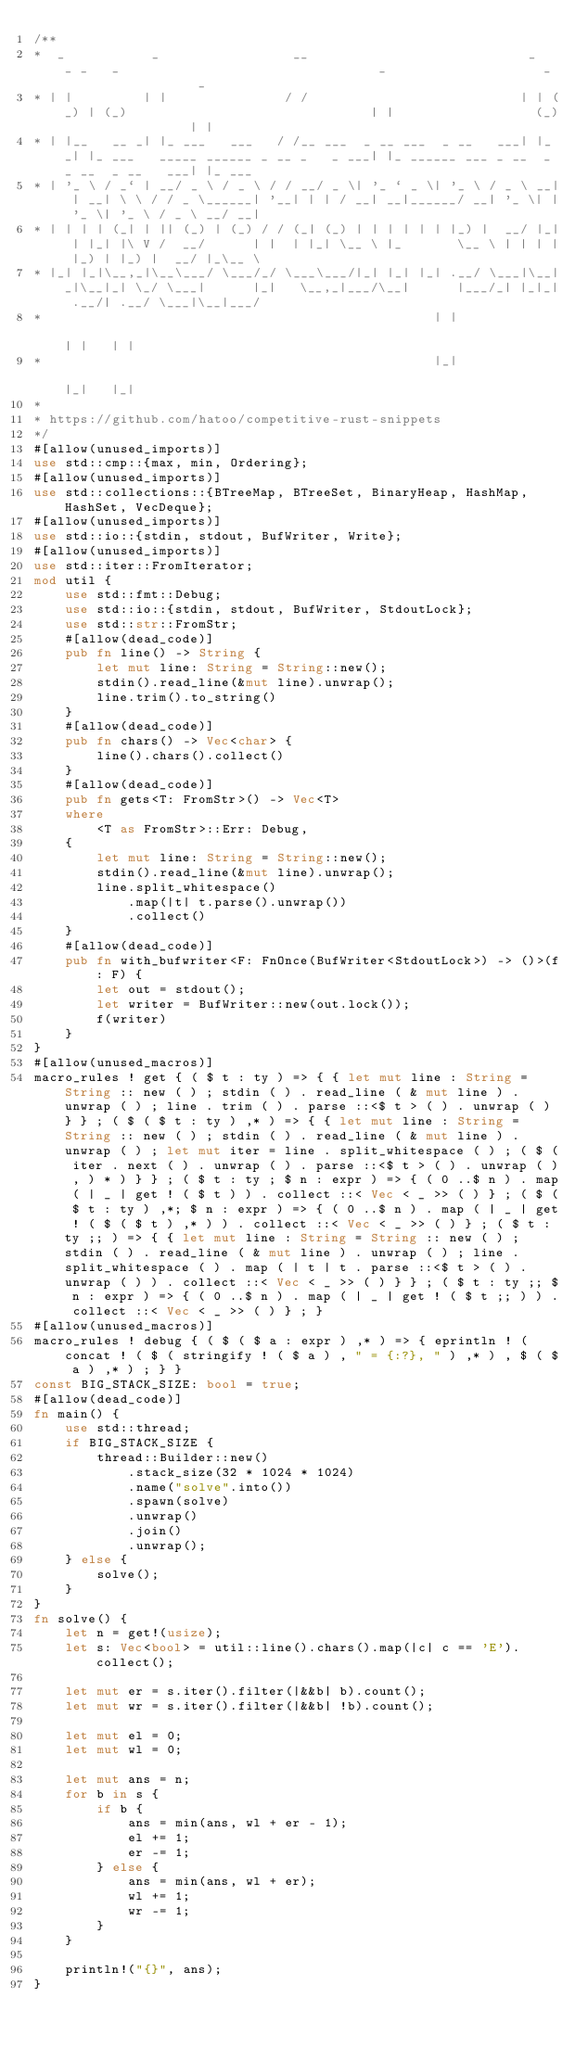Convert code to text. <code><loc_0><loc_0><loc_500><loc_500><_Rust_>/**
*  _           _                 __                            _   _ _   _                                 _                    _                  _
* | |         | |               / /                           | | (_) | (_)                               | |                  (_)                | |
* | |__   __ _| |_ ___   ___   / /__ ___  _ __ ___  _ __   ___| |_ _| |_ ___   _____ ______ _ __ _   _ ___| |_ ______ ___ _ __  _ _ __  _ __   ___| |_ ___
* | '_ \ / _` | __/ _ \ / _ \ / / __/ _ \| '_ ` _ \| '_ \ / _ \ __| | __| \ \ / / _ \______| '__| | | / __| __|______/ __| '_ \| | '_ \| '_ \ / _ \ __/ __|
* | | | | (_| | || (_) | (_) / / (_| (_) | | | | | | |_) |  __/ |_| | |_| |\ V /  __/      | |  | |_| \__ \ |_       \__ \ | | | | |_) | |_) |  __/ |_\__ \
* |_| |_|\__,_|\__\___/ \___/_/ \___\___/|_| |_| |_| .__/ \___|\__|_|\__|_| \_/ \___|      |_|   \__,_|___/\__|      |___/_| |_|_| .__/| .__/ \___|\__|___/
*                                                  | |                                                                           | |   | |
*                                                  |_|                                                                           |_|   |_|
*
* https://github.com/hatoo/competitive-rust-snippets
*/
#[allow(unused_imports)]
use std::cmp::{max, min, Ordering};
#[allow(unused_imports)]
use std::collections::{BTreeMap, BTreeSet, BinaryHeap, HashMap, HashSet, VecDeque};
#[allow(unused_imports)]
use std::io::{stdin, stdout, BufWriter, Write};
#[allow(unused_imports)]
use std::iter::FromIterator;
mod util {
    use std::fmt::Debug;
    use std::io::{stdin, stdout, BufWriter, StdoutLock};
    use std::str::FromStr;
    #[allow(dead_code)]
    pub fn line() -> String {
        let mut line: String = String::new();
        stdin().read_line(&mut line).unwrap();
        line.trim().to_string()
    }
    #[allow(dead_code)]
    pub fn chars() -> Vec<char> {
        line().chars().collect()
    }
    #[allow(dead_code)]
    pub fn gets<T: FromStr>() -> Vec<T>
    where
        <T as FromStr>::Err: Debug,
    {
        let mut line: String = String::new();
        stdin().read_line(&mut line).unwrap();
        line.split_whitespace()
            .map(|t| t.parse().unwrap())
            .collect()
    }
    #[allow(dead_code)]
    pub fn with_bufwriter<F: FnOnce(BufWriter<StdoutLock>) -> ()>(f: F) {
        let out = stdout();
        let writer = BufWriter::new(out.lock());
        f(writer)
    }
}
#[allow(unused_macros)]
macro_rules ! get { ( $ t : ty ) => { { let mut line : String = String :: new ( ) ; stdin ( ) . read_line ( & mut line ) . unwrap ( ) ; line . trim ( ) . parse ::<$ t > ( ) . unwrap ( ) } } ; ( $ ( $ t : ty ) ,* ) => { { let mut line : String = String :: new ( ) ; stdin ( ) . read_line ( & mut line ) . unwrap ( ) ; let mut iter = line . split_whitespace ( ) ; ( $ ( iter . next ( ) . unwrap ( ) . parse ::<$ t > ( ) . unwrap ( ) , ) * ) } } ; ( $ t : ty ; $ n : expr ) => { ( 0 ..$ n ) . map ( | _ | get ! ( $ t ) ) . collect ::< Vec < _ >> ( ) } ; ( $ ( $ t : ty ) ,*; $ n : expr ) => { ( 0 ..$ n ) . map ( | _ | get ! ( $ ( $ t ) ,* ) ) . collect ::< Vec < _ >> ( ) } ; ( $ t : ty ;; ) => { { let mut line : String = String :: new ( ) ; stdin ( ) . read_line ( & mut line ) . unwrap ( ) ; line . split_whitespace ( ) . map ( | t | t . parse ::<$ t > ( ) . unwrap ( ) ) . collect ::< Vec < _ >> ( ) } } ; ( $ t : ty ;; $ n : expr ) => { ( 0 ..$ n ) . map ( | _ | get ! ( $ t ;; ) ) . collect ::< Vec < _ >> ( ) } ; }
#[allow(unused_macros)]
macro_rules ! debug { ( $ ( $ a : expr ) ,* ) => { eprintln ! ( concat ! ( $ ( stringify ! ( $ a ) , " = {:?}, " ) ,* ) , $ ( $ a ) ,* ) ; } }
const BIG_STACK_SIZE: bool = true;
#[allow(dead_code)]
fn main() {
    use std::thread;
    if BIG_STACK_SIZE {
        thread::Builder::new()
            .stack_size(32 * 1024 * 1024)
            .name("solve".into())
            .spawn(solve)
            .unwrap()
            .join()
            .unwrap();
    } else {
        solve();
    }
}
fn solve() {
    let n = get!(usize);
    let s: Vec<bool> = util::line().chars().map(|c| c == 'E').collect();

    let mut er = s.iter().filter(|&&b| b).count();
    let mut wr = s.iter().filter(|&&b| !b).count();

    let mut el = 0;
    let mut wl = 0;

    let mut ans = n;
    for b in s {
        if b {
            ans = min(ans, wl + er - 1);
            el += 1;
            er -= 1;
        } else {
            ans = min(ans, wl + er);
            wl += 1;
            wr -= 1;
        }
    }

    println!("{}", ans);
}
</code> 